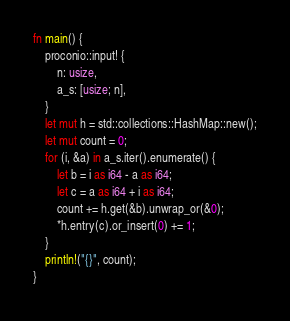<code> <loc_0><loc_0><loc_500><loc_500><_Rust_>fn main() {
    proconio::input! {
        n: usize,
        a_s: [usize; n],
    }
    let mut h = std::collections::HashMap::new();
    let mut count = 0;
    for (i, &a) in a_s.iter().enumerate() {
        let b = i as i64 - a as i64;
        let c = a as i64 + i as i64;
        count += h.get(&b).unwrap_or(&0);
        *h.entry(c).or_insert(0) += 1;
    }
    println!("{}", count);
}
</code> 